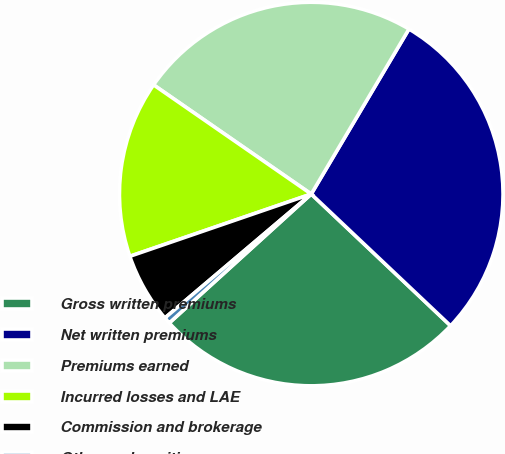Convert chart. <chart><loc_0><loc_0><loc_500><loc_500><pie_chart><fcel>Gross written premiums<fcel>Net written premiums<fcel>Premiums earned<fcel>Incurred losses and LAE<fcel>Commission and brokerage<fcel>Other underwriting expenses<nl><fcel>26.21%<fcel>28.54%<fcel>23.87%<fcel>14.9%<fcel>5.92%<fcel>0.55%<nl></chart> 